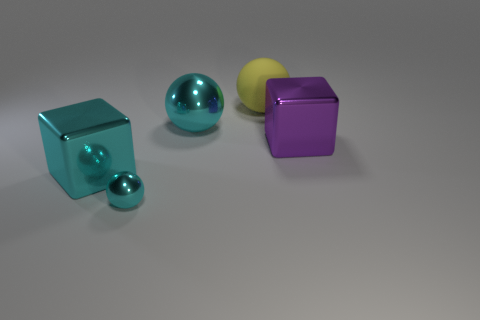There is a small object that is the same color as the big metal sphere; what is its shape?
Ensure brevity in your answer.  Sphere. Are the big purple block and the ball that is right of the large shiny sphere made of the same material?
Offer a very short reply. No. Is there anything else that has the same material as the big yellow ball?
Your answer should be very brief. No. What size is the cyan metallic object that is the same shape as the large purple thing?
Your answer should be very brief. Large. What size is the ball that is to the right of the tiny cyan metal object and in front of the rubber sphere?
Your response must be concise. Large. There is a large matte thing; is it the same color as the thing that is on the right side of the large yellow ball?
Offer a terse response. No. How many yellow things are large matte cylinders or large metal blocks?
Your answer should be very brief. 0. The small object is what shape?
Ensure brevity in your answer.  Sphere. What number of other objects are there of the same shape as the purple metallic thing?
Keep it short and to the point. 1. The large cube to the right of the large cyan block is what color?
Provide a succinct answer. Purple. 